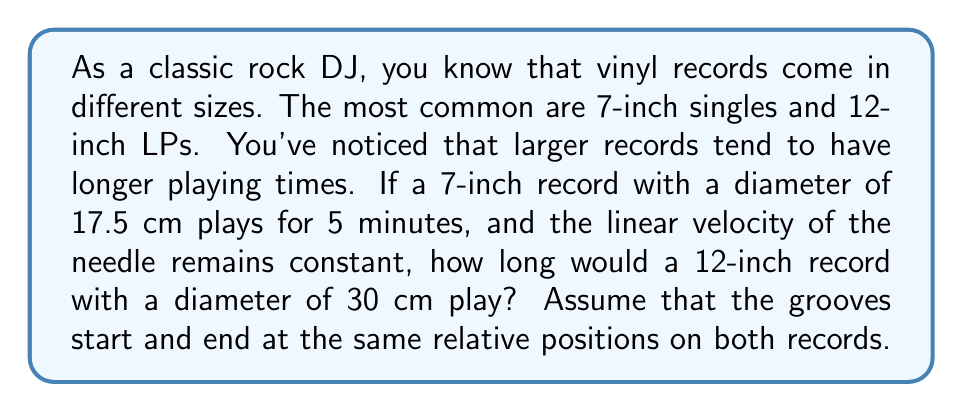Can you answer this question? Let's approach this step-by-step:

1) First, we need to understand that the playing time is directly proportional to the length of the groove on the record. The groove forms a spiral from the outer edge to the inner edge of the playable area.

2) We can approximate the length of the groove as the circumference of a circle multiplied by the number of rotations. The number of rotations is constant for both records if we assume the grooves start and end at the same relative positions.

3) The circumference of a circle is given by the formula $C = \pi d$, where $d$ is the diameter.

4) Let's set up a proportion:

   $$\frac{\text{Time}_1}{\text{Time}_2} = \frac{\text{Circumference}_1}{\text{Circumference}_2}$$

5) We know:
   - $\text{Time}_1 = 5$ minutes
   - $\text{Diameter}_1 = 17.5$ cm
   - $\text{Diameter}_2 = 30$ cm

6) Substituting these values:

   $$\frac{5}{\text{Time}_2} = \frac{\pi(17.5)}{\pi(30)}$$

7) The $\pi$ cancels out:

   $$\frac{5}{\text{Time}_2} = \frac{17.5}{30}$$

8) Cross multiply:

   $$5(30) = \text{Time}_2(17.5)$$

9) Solve for $\text{Time}_2$:

   $$\text{Time}_2 = \frac{5(30)}{17.5} = \frac{150}{17.5} \approx 8.57$$

Therefore, the 12-inch record would play for approximately 8.57 minutes.
Answer: The 12-inch record would play for approximately 8.57 minutes. 